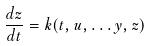<formula> <loc_0><loc_0><loc_500><loc_500>\frac { d z } { d t } = k ( t , u , \dots y , z )</formula> 